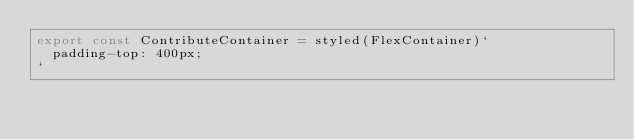Convert code to text. <code><loc_0><loc_0><loc_500><loc_500><_TypeScript_>export const ContributeContainer = styled(FlexContainer)`
  padding-top: 400px;
`</code> 